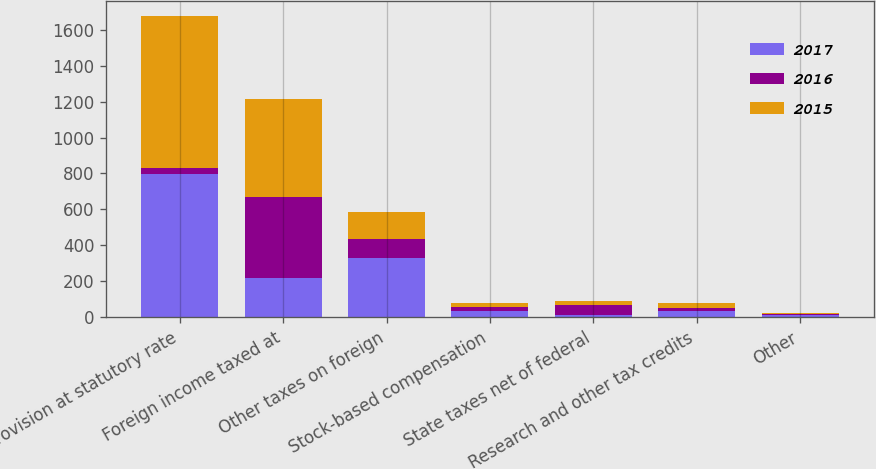Convert chart to OTSL. <chart><loc_0><loc_0><loc_500><loc_500><stacked_bar_chart><ecel><fcel>Provision at statutory rate<fcel>Foreign income taxed at<fcel>Other taxes on foreign<fcel>Stock-based compensation<fcel>State taxes net of federal<fcel>Research and other tax credits<fcel>Other<nl><fcel>2017<fcel>797<fcel>217<fcel>330<fcel>33<fcel>13<fcel>35<fcel>12<nl><fcel>2016<fcel>34<fcel>451<fcel>105<fcel>24<fcel>55<fcel>16<fcel>8<nl><fcel>2015<fcel>843<fcel>549<fcel>150<fcel>23<fcel>20<fcel>27<fcel>1<nl></chart> 